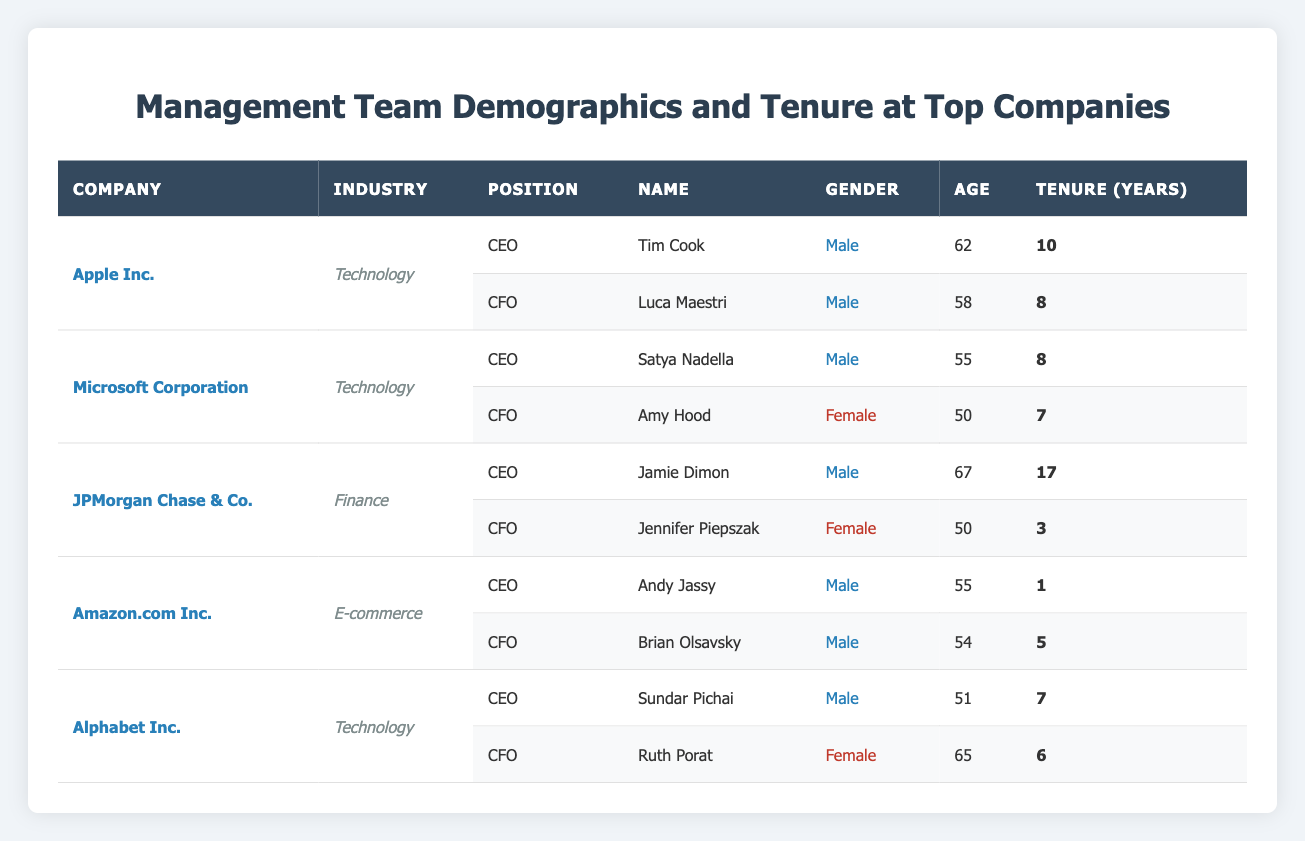What is the age of the CFO at Apple Inc.? The table lists Luca Maestri as the CFO of Apple Inc. with an age of 58.
Answer: 58 How many years has the CEO of JPMorgan Chase & Co. been in tenure? Jamie Dimon, CEO of JPMorgan Chase & Co., has a tenure of 17 years, as stated in the table.
Answer: 17 Which company has the oldest CEO? The table shows Jamie Dimon of JPMorgan Chase & Co. as the oldest CEO at age 67, compared to other CEOs listed.
Answer: JPMorgan Chase & Co What is the average tenure of the CFOs listed in the table? The tenures of the CFOs are 8 (Apple), 7 (Microsoft), 3 (JPMorgan), 5 (Amazon), and 6 (Alphabet), totaling 29 years. There are 5 CFOs, so the average is 29/5 = 5.8.
Answer: 5.8 Is there a female CFO at Microsoft Corporation? The table indicates that Amy Hood is the CFO at Microsoft Corporation and she is female. Therefore, the statement is true.
Answer: Yes Which company has the highest combined age of its management team? To find the company with the highest combined age, we add the ages of the management teams: Apple (62 + 58 = 120), Microsoft (55 + 50 = 105), JPMorgan (67 + 50 = 117), Amazon (55 + 54 = 109), Alphabet (51 + 65 = 116). Apple Inc. has the highest combined age of 120.
Answer: Apple Inc What percentage of the management team at Google Inc. is male? Alphabet Inc. has 1 female (Ruth Porat) and 1 male (Sundar Pichai) in its management team. Thus, the percentage of males is (1 male / 2 total) * 100 = 50%.
Answer: 50% Who has been in their position the shortest time? Referring to the tenures, Andy Jassy at Amazon has been CEO for only 1 year, the shortest among the teams.
Answer: Andy Jassy How many male executives are there across all companies? The table lists a total of 7 executives: Tim Cook, Luca Maestri (Apple), Satya Nadella (Microsoft), Jamie Dimon (JPMorgan), Andy Jassy, Brian Olsavsky (Amazon), Sundar Pichai (Alphabet). This sums up to 5 male executives in total.
Answer: 5 